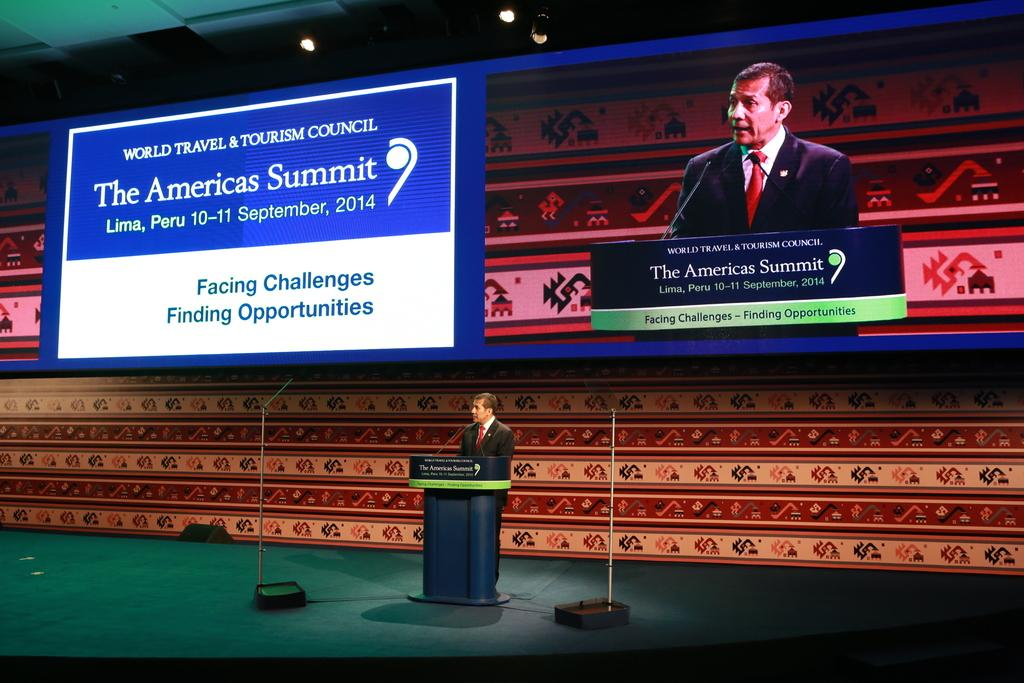Who is the main subject in the image? There is a man in the image. What is the man doing in the image? The man is standing in front of a podium. What objects are near the man? There are microphones beside the man. What can be seen in the background of the image? There is a screen and lights visible in the background of the image. What type of base can be seen supporting the man in the image? There is no base supporting the man in the image; he is standing on the ground. 